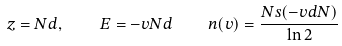Convert formula to latex. <formula><loc_0><loc_0><loc_500><loc_500>z = N d , \quad E = - v N d \quad n ( v ) = \frac { N s ( - v d N ) } { \ln 2 }</formula> 